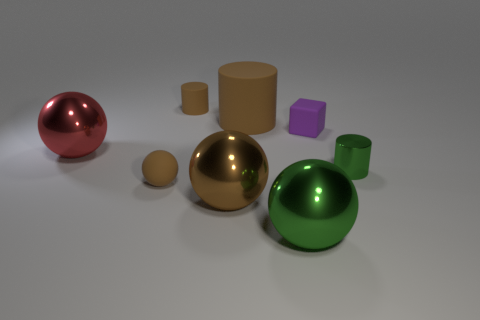Do the tiny shiny thing and the large object that is behind the red shiny thing have the same shape? Yes, they do. The small shiny object is a sphere, exactly like the large golden sphere located behind the red shiny hemisphere. Despite their difference in size and color, they both share the spherical shape. 